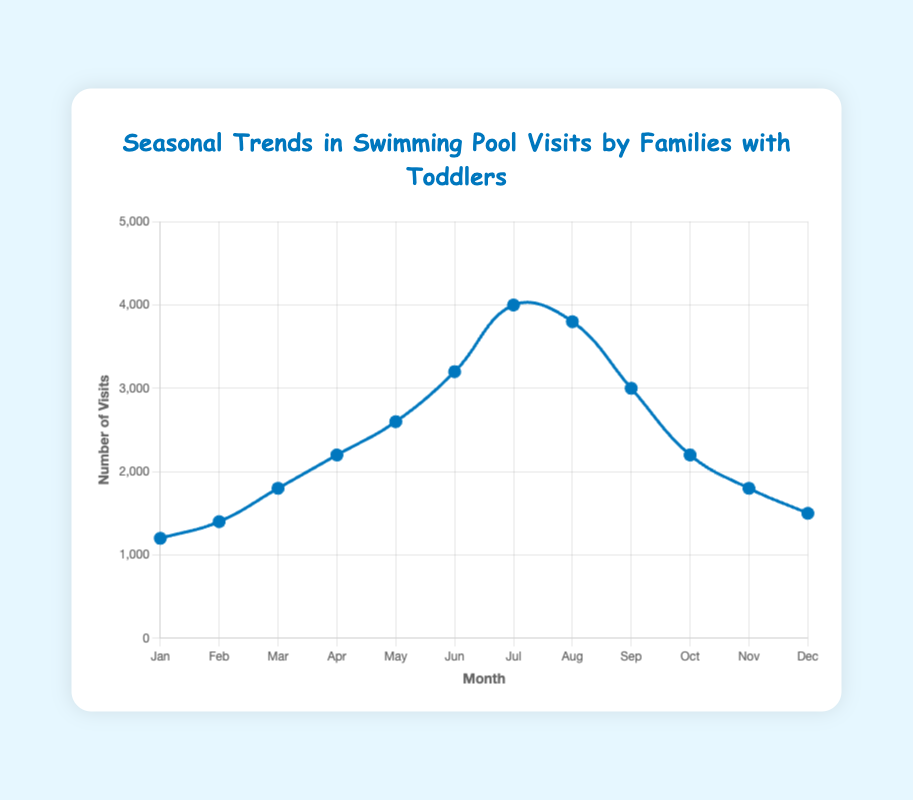Which month had the highest number of pool visits? The figure shows the number of pool visits for each month. By comparing the heights of each data point, we see that July has the highest value of visits.
Answer: July What is the difference in the number of visits between the month with the highest visits and the month with the lowest visits? The highest number of visits is in July (4000 visits) and the lowest is in January (1200 visits). Subtracting these two values gives the difference: 4000 - 1200 = 2800 visits.
Answer: 2800 Which month saw a higher number of pool visits, April or October? By comparing the data points for April and October on the figure, we see April has 2200 visits and October has 2200 visits.
Answer: Equal What is the average number of visits in the first quarter of the year (January, February, March)? Summing the visits for January (1200), February (1400), and March (1800) gives a total of 4400 visits. The average is calculated by dividing the total by 3: 4400 / 3 = 1466.67 visits.
Answer: 1466.67 Did the number of visits increase or decrease from August to September? By examining the data points for August (3800 visits) and September (3000 visits) on the figure, we see a decrease in visits.
Answer: Decrease What is the total number of visits for the summer months (June, July, August)? Summing the visits for June (3200), July (4000), and August (3800) yields a total: 3200 + 4000 + 3800 = 11000 visits.
Answer: 11000 In which month did the visits first surpass 3000? The data points show that the number of visits first surpassed 3000 in June, which has 3200 visits.
Answer: June Is the number of pool visits in May closer to that in April or June? The visit numbers are 2600 in May, 2200 in April, and 3200 in June. Calculating the difference, we get:
Answer: Closer to April.
Difference with April: 2600 - 2200 = 400
Difference with June: 3200 - 2600 = 600 Identify the months where the visit numbers saw a decrease compared to the previous month. According to the data points, the months where visits decrease compared to the previous month are:
- August to September (3800 to 3000)
- September to October (3000 to 2200)
- October to November (2200 to 1800)
- November to December (1800 to 1500)
Answer: August to September, September to October, October to November, November to December 